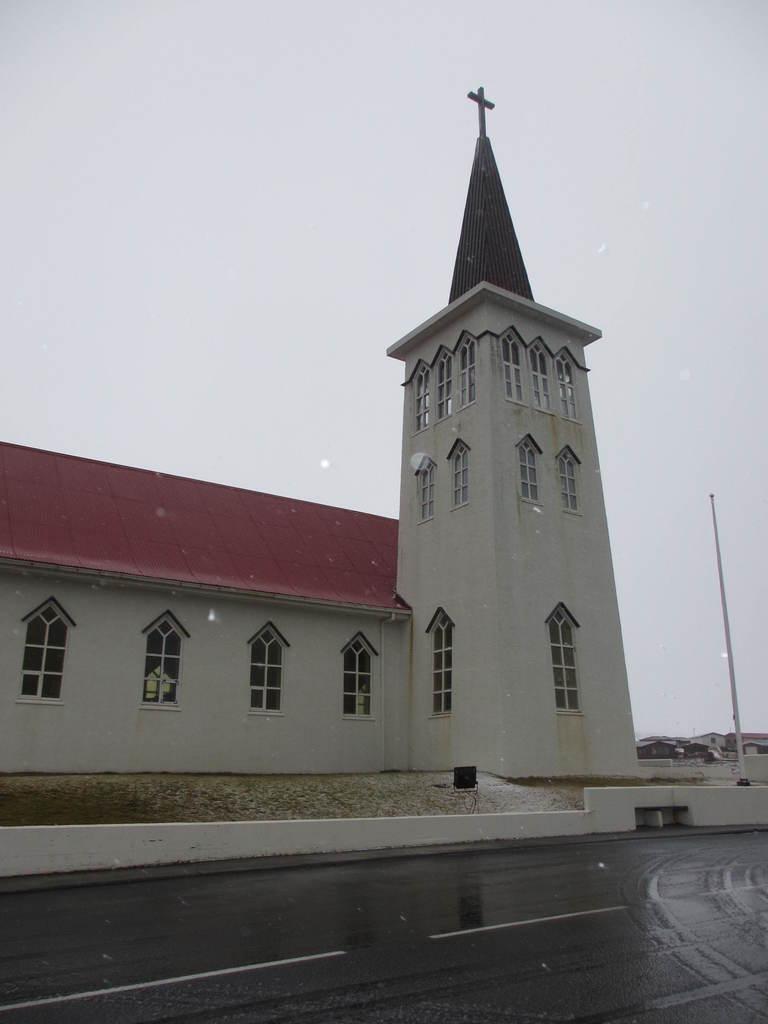How would you summarize this image in a sentence or two? In the image there is a church on the side of the road and behind there are homes and above its sky. 